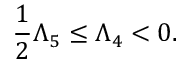Convert formula to latex. <formula><loc_0><loc_0><loc_500><loc_500>\frac { 1 } { 2 } \Lambda _ { 5 } \leq \Lambda _ { 4 } < 0 .</formula> 